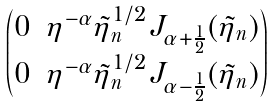<formula> <loc_0><loc_0><loc_500><loc_500>\begin{pmatrix} 0 & \eta ^ { - \alpha } \tilde { \eta } _ { n } ^ { 1 / 2 } J _ { \alpha + \frac { 1 } { 2 } } ( \tilde { \eta } _ { n } ) \\ 0 & \eta ^ { - \alpha } \tilde { \eta } _ { n } ^ { 1 / 2 } J _ { \alpha - \frac { 1 } { 2 } } ( \tilde { \eta } _ { n } ) \end{pmatrix}</formula> 